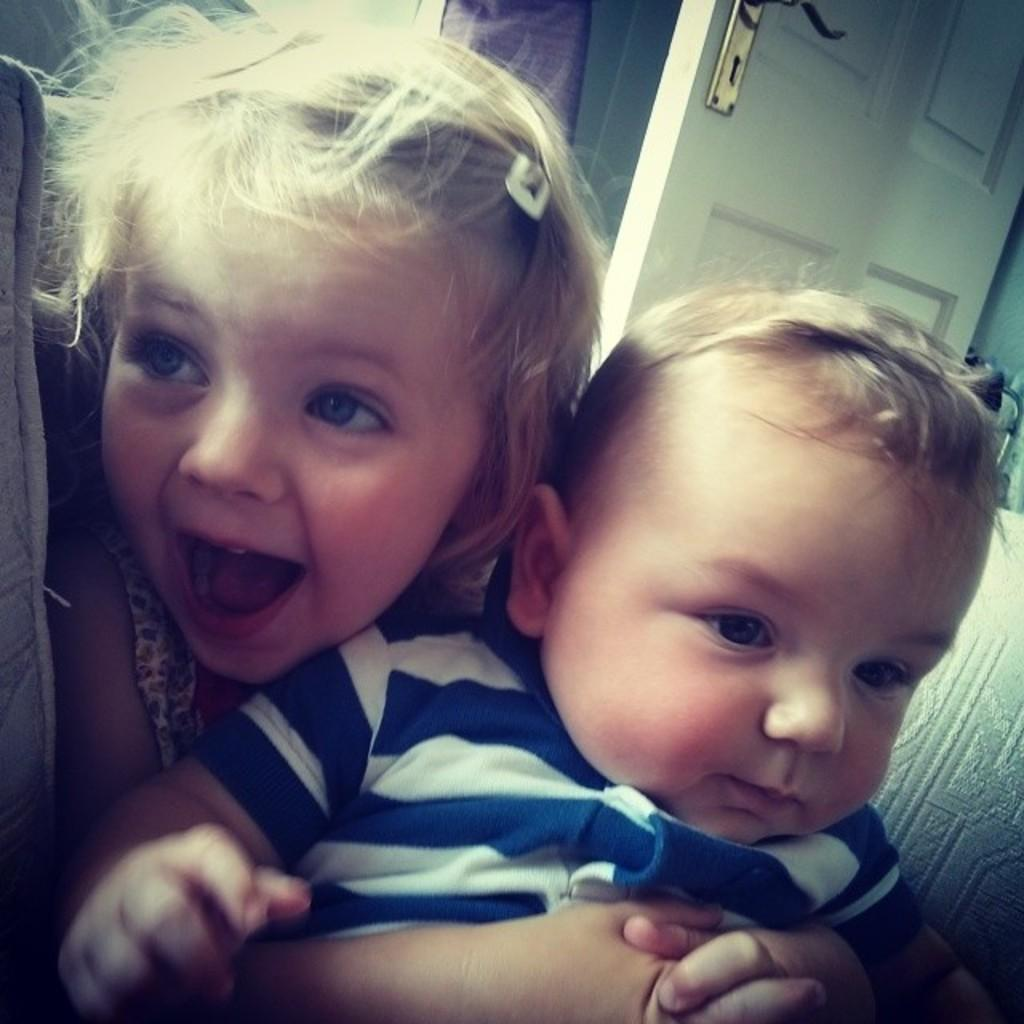How many children are present in the image? There are two children in the image. What are the children doing in the image? The children are sitting on a sofa. Can you describe any other objects or features in the image? There is a door visible in the image. What type of peace treaty is being discussed by the children in the image? There is no indication in the image that the children are discussing a peace treaty or any type of meeting. 